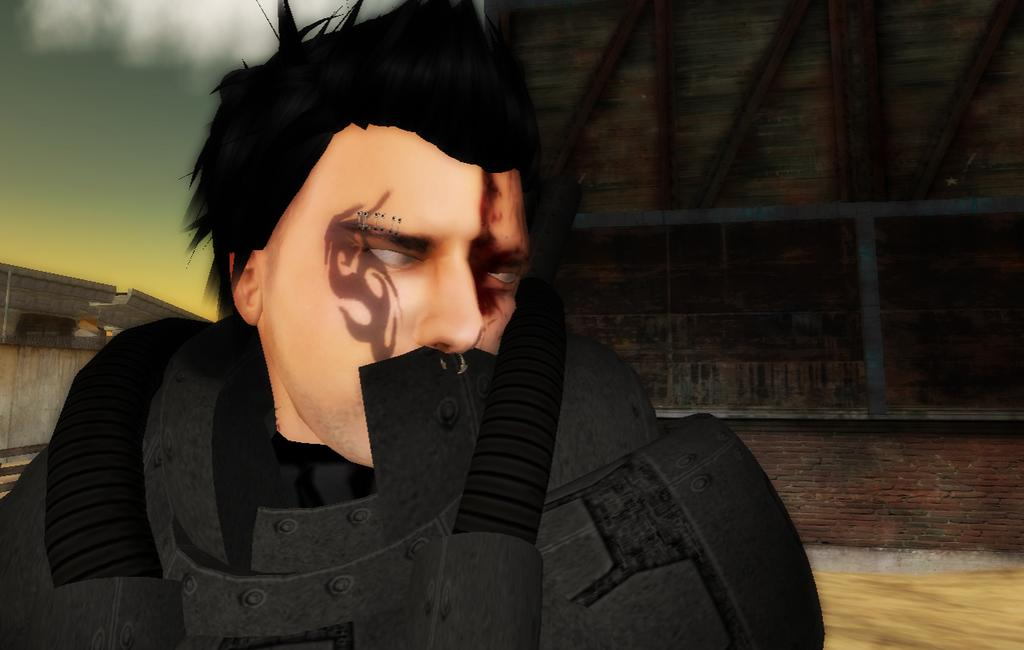What type of picture is in the image? The image contains an animated picture. Can you describe the person in the animated picture? There is a person in the animated image. What can be seen in the background of the image? There is a brick wall in the background of the image, and there are objects visible as well. What type of company is depicted in the image? There is no company depicted in the image; it contains an animated picture with a person and a brick wall in the background. How many zebras can be seen in the image? There are no zebras present in the image. 